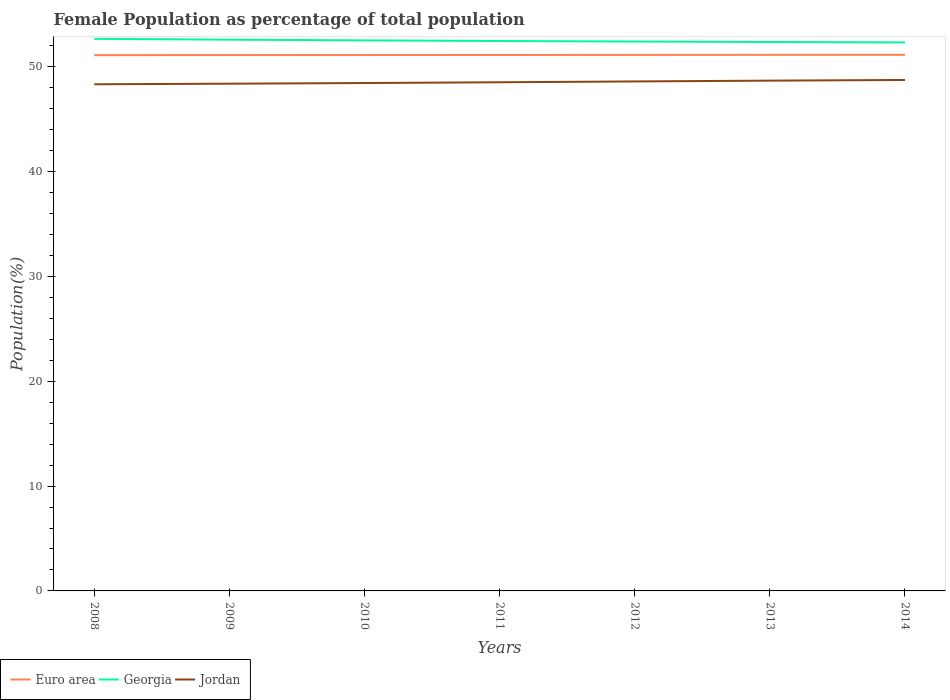How many different coloured lines are there?
Your answer should be very brief. 3. Is the number of lines equal to the number of legend labels?
Provide a succinct answer. Yes. Across all years, what is the maximum female population in in Georgia?
Provide a succinct answer. 52.33. What is the total female population in in Jordan in the graph?
Ensure brevity in your answer.  -0.06. What is the difference between the highest and the second highest female population in in Euro area?
Your response must be concise. 0.03. What is the difference between two consecutive major ticks on the Y-axis?
Your response must be concise. 10. How are the legend labels stacked?
Ensure brevity in your answer.  Horizontal. What is the title of the graph?
Keep it short and to the point. Female Population as percentage of total population. Does "Dominica" appear as one of the legend labels in the graph?
Your response must be concise. No. What is the label or title of the Y-axis?
Ensure brevity in your answer.  Population(%). What is the Population(%) of Euro area in 2008?
Your response must be concise. 51.12. What is the Population(%) in Georgia in 2008?
Offer a terse response. 52.67. What is the Population(%) in Jordan in 2008?
Your response must be concise. 48.34. What is the Population(%) of Euro area in 2009?
Give a very brief answer. 51.12. What is the Population(%) in Georgia in 2009?
Provide a short and direct response. 52.59. What is the Population(%) of Jordan in 2009?
Provide a short and direct response. 48.39. What is the Population(%) of Euro area in 2010?
Offer a terse response. 51.13. What is the Population(%) of Georgia in 2010?
Offer a terse response. 52.52. What is the Population(%) in Jordan in 2010?
Ensure brevity in your answer.  48.45. What is the Population(%) of Euro area in 2011?
Keep it short and to the point. 51.13. What is the Population(%) in Georgia in 2011?
Provide a succinct answer. 52.46. What is the Population(%) of Jordan in 2011?
Offer a terse response. 48.53. What is the Population(%) in Euro area in 2012?
Offer a terse response. 51.14. What is the Population(%) of Georgia in 2012?
Your response must be concise. 52.41. What is the Population(%) of Jordan in 2012?
Your answer should be compact. 48.61. What is the Population(%) in Euro area in 2013?
Offer a very short reply. 51.14. What is the Population(%) of Georgia in 2013?
Make the answer very short. 52.37. What is the Population(%) in Jordan in 2013?
Provide a short and direct response. 48.68. What is the Population(%) in Euro area in 2014?
Your answer should be very brief. 51.14. What is the Population(%) in Georgia in 2014?
Provide a succinct answer. 52.33. What is the Population(%) in Jordan in 2014?
Ensure brevity in your answer.  48.75. Across all years, what is the maximum Population(%) of Euro area?
Give a very brief answer. 51.14. Across all years, what is the maximum Population(%) of Georgia?
Make the answer very short. 52.67. Across all years, what is the maximum Population(%) in Jordan?
Provide a short and direct response. 48.75. Across all years, what is the minimum Population(%) of Euro area?
Your answer should be very brief. 51.12. Across all years, what is the minimum Population(%) in Georgia?
Provide a succinct answer. 52.33. Across all years, what is the minimum Population(%) of Jordan?
Ensure brevity in your answer.  48.34. What is the total Population(%) in Euro area in the graph?
Offer a very short reply. 357.92. What is the total Population(%) of Georgia in the graph?
Your answer should be very brief. 367.37. What is the total Population(%) of Jordan in the graph?
Give a very brief answer. 339.75. What is the difference between the Population(%) in Euro area in 2008 and that in 2009?
Your answer should be very brief. -0. What is the difference between the Population(%) of Georgia in 2008 and that in 2009?
Ensure brevity in your answer.  0.08. What is the difference between the Population(%) in Jordan in 2008 and that in 2009?
Provide a short and direct response. -0.05. What is the difference between the Population(%) of Euro area in 2008 and that in 2010?
Provide a succinct answer. -0.01. What is the difference between the Population(%) of Georgia in 2008 and that in 2010?
Your answer should be very brief. 0.15. What is the difference between the Population(%) of Jordan in 2008 and that in 2010?
Give a very brief answer. -0.12. What is the difference between the Population(%) of Euro area in 2008 and that in 2011?
Ensure brevity in your answer.  -0.01. What is the difference between the Population(%) in Georgia in 2008 and that in 2011?
Provide a short and direct response. 0.21. What is the difference between the Population(%) in Jordan in 2008 and that in 2011?
Offer a terse response. -0.19. What is the difference between the Population(%) of Euro area in 2008 and that in 2012?
Offer a terse response. -0.02. What is the difference between the Population(%) of Georgia in 2008 and that in 2012?
Your answer should be compact. 0.26. What is the difference between the Population(%) of Jordan in 2008 and that in 2012?
Offer a terse response. -0.27. What is the difference between the Population(%) of Euro area in 2008 and that in 2013?
Ensure brevity in your answer.  -0.03. What is the difference between the Population(%) of Georgia in 2008 and that in 2013?
Provide a short and direct response. 0.3. What is the difference between the Population(%) in Jordan in 2008 and that in 2013?
Your answer should be compact. -0.35. What is the difference between the Population(%) of Euro area in 2008 and that in 2014?
Provide a short and direct response. -0.03. What is the difference between the Population(%) in Georgia in 2008 and that in 2014?
Keep it short and to the point. 0.34. What is the difference between the Population(%) of Jordan in 2008 and that in 2014?
Your response must be concise. -0.41. What is the difference between the Population(%) of Euro area in 2009 and that in 2010?
Your answer should be compact. -0. What is the difference between the Population(%) of Georgia in 2009 and that in 2010?
Provide a succinct answer. 0.07. What is the difference between the Population(%) of Jordan in 2009 and that in 2010?
Offer a very short reply. -0.06. What is the difference between the Population(%) in Euro area in 2009 and that in 2011?
Give a very brief answer. -0.01. What is the difference between the Population(%) of Georgia in 2009 and that in 2011?
Offer a terse response. 0.13. What is the difference between the Population(%) in Jordan in 2009 and that in 2011?
Give a very brief answer. -0.14. What is the difference between the Population(%) of Euro area in 2009 and that in 2012?
Give a very brief answer. -0.02. What is the difference between the Population(%) in Georgia in 2009 and that in 2012?
Make the answer very short. 0.18. What is the difference between the Population(%) in Jordan in 2009 and that in 2012?
Keep it short and to the point. -0.21. What is the difference between the Population(%) of Euro area in 2009 and that in 2013?
Provide a short and direct response. -0.02. What is the difference between the Population(%) in Georgia in 2009 and that in 2013?
Offer a terse response. 0.22. What is the difference between the Population(%) of Jordan in 2009 and that in 2013?
Your answer should be very brief. -0.29. What is the difference between the Population(%) in Euro area in 2009 and that in 2014?
Keep it short and to the point. -0.02. What is the difference between the Population(%) in Georgia in 2009 and that in 2014?
Provide a succinct answer. 0.26. What is the difference between the Population(%) of Jordan in 2009 and that in 2014?
Provide a short and direct response. -0.36. What is the difference between the Population(%) of Euro area in 2010 and that in 2011?
Offer a very short reply. -0.01. What is the difference between the Population(%) of Georgia in 2010 and that in 2011?
Offer a very short reply. 0.06. What is the difference between the Population(%) of Jordan in 2010 and that in 2011?
Provide a succinct answer. -0.07. What is the difference between the Population(%) in Euro area in 2010 and that in 2012?
Ensure brevity in your answer.  -0.01. What is the difference between the Population(%) in Georgia in 2010 and that in 2012?
Your answer should be very brief. 0.11. What is the difference between the Population(%) in Jordan in 2010 and that in 2012?
Give a very brief answer. -0.15. What is the difference between the Population(%) of Euro area in 2010 and that in 2013?
Ensure brevity in your answer.  -0.02. What is the difference between the Population(%) of Georgia in 2010 and that in 2013?
Make the answer very short. 0.15. What is the difference between the Population(%) in Jordan in 2010 and that in 2013?
Offer a terse response. -0.23. What is the difference between the Population(%) of Euro area in 2010 and that in 2014?
Ensure brevity in your answer.  -0.02. What is the difference between the Population(%) in Georgia in 2010 and that in 2014?
Your answer should be very brief. 0.19. What is the difference between the Population(%) of Jordan in 2010 and that in 2014?
Offer a very short reply. -0.29. What is the difference between the Population(%) of Euro area in 2011 and that in 2012?
Provide a succinct answer. -0.01. What is the difference between the Population(%) of Georgia in 2011 and that in 2012?
Offer a terse response. 0.05. What is the difference between the Population(%) in Jordan in 2011 and that in 2012?
Provide a succinct answer. -0.08. What is the difference between the Population(%) of Euro area in 2011 and that in 2013?
Provide a succinct answer. -0.01. What is the difference between the Population(%) in Georgia in 2011 and that in 2013?
Ensure brevity in your answer.  0.09. What is the difference between the Population(%) in Jordan in 2011 and that in 2013?
Give a very brief answer. -0.16. What is the difference between the Population(%) in Euro area in 2011 and that in 2014?
Offer a terse response. -0.01. What is the difference between the Population(%) of Georgia in 2011 and that in 2014?
Offer a very short reply. 0.13. What is the difference between the Population(%) of Jordan in 2011 and that in 2014?
Keep it short and to the point. -0.22. What is the difference between the Population(%) in Euro area in 2012 and that in 2013?
Provide a short and direct response. -0.01. What is the difference between the Population(%) of Georgia in 2012 and that in 2013?
Offer a very short reply. 0.04. What is the difference between the Population(%) of Jordan in 2012 and that in 2013?
Your answer should be compact. -0.08. What is the difference between the Population(%) of Euro area in 2012 and that in 2014?
Give a very brief answer. -0.01. What is the difference between the Population(%) of Georgia in 2012 and that in 2014?
Your answer should be very brief. 0.08. What is the difference between the Population(%) in Jordan in 2012 and that in 2014?
Keep it short and to the point. -0.14. What is the difference between the Population(%) in Euro area in 2013 and that in 2014?
Provide a succinct answer. -0. What is the difference between the Population(%) of Georgia in 2013 and that in 2014?
Offer a very short reply. 0.04. What is the difference between the Population(%) in Jordan in 2013 and that in 2014?
Make the answer very short. -0.06. What is the difference between the Population(%) of Euro area in 2008 and the Population(%) of Georgia in 2009?
Make the answer very short. -1.48. What is the difference between the Population(%) in Euro area in 2008 and the Population(%) in Jordan in 2009?
Make the answer very short. 2.72. What is the difference between the Population(%) in Georgia in 2008 and the Population(%) in Jordan in 2009?
Your answer should be compact. 4.28. What is the difference between the Population(%) of Euro area in 2008 and the Population(%) of Georgia in 2010?
Your response must be concise. -1.41. What is the difference between the Population(%) of Euro area in 2008 and the Population(%) of Jordan in 2010?
Offer a very short reply. 2.66. What is the difference between the Population(%) in Georgia in 2008 and the Population(%) in Jordan in 2010?
Provide a short and direct response. 4.22. What is the difference between the Population(%) in Euro area in 2008 and the Population(%) in Georgia in 2011?
Your answer should be very brief. -1.35. What is the difference between the Population(%) of Euro area in 2008 and the Population(%) of Jordan in 2011?
Offer a very short reply. 2.59. What is the difference between the Population(%) of Georgia in 2008 and the Population(%) of Jordan in 2011?
Provide a succinct answer. 4.14. What is the difference between the Population(%) in Euro area in 2008 and the Population(%) in Georgia in 2012?
Your answer should be very brief. -1.3. What is the difference between the Population(%) of Euro area in 2008 and the Population(%) of Jordan in 2012?
Your answer should be very brief. 2.51. What is the difference between the Population(%) in Georgia in 2008 and the Population(%) in Jordan in 2012?
Provide a short and direct response. 4.06. What is the difference between the Population(%) in Euro area in 2008 and the Population(%) in Georgia in 2013?
Provide a succinct answer. -1.25. What is the difference between the Population(%) of Euro area in 2008 and the Population(%) of Jordan in 2013?
Your response must be concise. 2.43. What is the difference between the Population(%) in Georgia in 2008 and the Population(%) in Jordan in 2013?
Give a very brief answer. 3.99. What is the difference between the Population(%) in Euro area in 2008 and the Population(%) in Georgia in 2014?
Your answer should be compact. -1.22. What is the difference between the Population(%) in Euro area in 2008 and the Population(%) in Jordan in 2014?
Offer a very short reply. 2.37. What is the difference between the Population(%) in Georgia in 2008 and the Population(%) in Jordan in 2014?
Make the answer very short. 3.92. What is the difference between the Population(%) of Euro area in 2009 and the Population(%) of Georgia in 2010?
Your response must be concise. -1.4. What is the difference between the Population(%) in Euro area in 2009 and the Population(%) in Jordan in 2010?
Give a very brief answer. 2.67. What is the difference between the Population(%) in Georgia in 2009 and the Population(%) in Jordan in 2010?
Your answer should be compact. 4.14. What is the difference between the Population(%) of Euro area in 2009 and the Population(%) of Georgia in 2011?
Your response must be concise. -1.34. What is the difference between the Population(%) in Euro area in 2009 and the Population(%) in Jordan in 2011?
Make the answer very short. 2.59. What is the difference between the Population(%) of Georgia in 2009 and the Population(%) of Jordan in 2011?
Provide a short and direct response. 4.07. What is the difference between the Population(%) in Euro area in 2009 and the Population(%) in Georgia in 2012?
Your answer should be very brief. -1.29. What is the difference between the Population(%) of Euro area in 2009 and the Population(%) of Jordan in 2012?
Keep it short and to the point. 2.51. What is the difference between the Population(%) in Georgia in 2009 and the Population(%) in Jordan in 2012?
Offer a terse response. 3.99. What is the difference between the Population(%) in Euro area in 2009 and the Population(%) in Georgia in 2013?
Provide a short and direct response. -1.25. What is the difference between the Population(%) in Euro area in 2009 and the Population(%) in Jordan in 2013?
Provide a succinct answer. 2.44. What is the difference between the Population(%) in Georgia in 2009 and the Population(%) in Jordan in 2013?
Offer a terse response. 3.91. What is the difference between the Population(%) in Euro area in 2009 and the Population(%) in Georgia in 2014?
Keep it short and to the point. -1.21. What is the difference between the Population(%) of Euro area in 2009 and the Population(%) of Jordan in 2014?
Make the answer very short. 2.37. What is the difference between the Population(%) of Georgia in 2009 and the Population(%) of Jordan in 2014?
Your answer should be very brief. 3.85. What is the difference between the Population(%) of Euro area in 2010 and the Population(%) of Georgia in 2011?
Your answer should be very brief. -1.34. What is the difference between the Population(%) of Euro area in 2010 and the Population(%) of Jordan in 2011?
Give a very brief answer. 2.6. What is the difference between the Population(%) in Georgia in 2010 and the Population(%) in Jordan in 2011?
Keep it short and to the point. 4. What is the difference between the Population(%) in Euro area in 2010 and the Population(%) in Georgia in 2012?
Your answer should be very brief. -1.29. What is the difference between the Population(%) of Euro area in 2010 and the Population(%) of Jordan in 2012?
Your answer should be compact. 2.52. What is the difference between the Population(%) of Georgia in 2010 and the Population(%) of Jordan in 2012?
Your response must be concise. 3.92. What is the difference between the Population(%) of Euro area in 2010 and the Population(%) of Georgia in 2013?
Your answer should be compact. -1.24. What is the difference between the Population(%) of Euro area in 2010 and the Population(%) of Jordan in 2013?
Offer a very short reply. 2.44. What is the difference between the Population(%) in Georgia in 2010 and the Population(%) in Jordan in 2013?
Your answer should be very brief. 3.84. What is the difference between the Population(%) of Euro area in 2010 and the Population(%) of Georgia in 2014?
Ensure brevity in your answer.  -1.21. What is the difference between the Population(%) in Euro area in 2010 and the Population(%) in Jordan in 2014?
Offer a very short reply. 2.38. What is the difference between the Population(%) of Georgia in 2010 and the Population(%) of Jordan in 2014?
Your answer should be very brief. 3.78. What is the difference between the Population(%) in Euro area in 2011 and the Population(%) in Georgia in 2012?
Provide a short and direct response. -1.28. What is the difference between the Population(%) in Euro area in 2011 and the Population(%) in Jordan in 2012?
Provide a short and direct response. 2.52. What is the difference between the Population(%) of Georgia in 2011 and the Population(%) of Jordan in 2012?
Provide a succinct answer. 3.86. What is the difference between the Population(%) in Euro area in 2011 and the Population(%) in Georgia in 2013?
Provide a succinct answer. -1.24. What is the difference between the Population(%) in Euro area in 2011 and the Population(%) in Jordan in 2013?
Keep it short and to the point. 2.45. What is the difference between the Population(%) of Georgia in 2011 and the Population(%) of Jordan in 2013?
Offer a very short reply. 3.78. What is the difference between the Population(%) of Euro area in 2011 and the Population(%) of Georgia in 2014?
Offer a terse response. -1.2. What is the difference between the Population(%) of Euro area in 2011 and the Population(%) of Jordan in 2014?
Provide a short and direct response. 2.38. What is the difference between the Population(%) in Georgia in 2011 and the Population(%) in Jordan in 2014?
Give a very brief answer. 3.72. What is the difference between the Population(%) in Euro area in 2012 and the Population(%) in Georgia in 2013?
Offer a terse response. -1.23. What is the difference between the Population(%) of Euro area in 2012 and the Population(%) of Jordan in 2013?
Your answer should be very brief. 2.45. What is the difference between the Population(%) of Georgia in 2012 and the Population(%) of Jordan in 2013?
Make the answer very short. 3.73. What is the difference between the Population(%) in Euro area in 2012 and the Population(%) in Georgia in 2014?
Provide a short and direct response. -1.19. What is the difference between the Population(%) in Euro area in 2012 and the Population(%) in Jordan in 2014?
Your response must be concise. 2.39. What is the difference between the Population(%) in Georgia in 2012 and the Population(%) in Jordan in 2014?
Provide a short and direct response. 3.67. What is the difference between the Population(%) in Euro area in 2013 and the Population(%) in Georgia in 2014?
Ensure brevity in your answer.  -1.19. What is the difference between the Population(%) of Euro area in 2013 and the Population(%) of Jordan in 2014?
Make the answer very short. 2.4. What is the difference between the Population(%) in Georgia in 2013 and the Population(%) in Jordan in 2014?
Offer a terse response. 3.62. What is the average Population(%) of Euro area per year?
Your answer should be very brief. 51.13. What is the average Population(%) in Georgia per year?
Make the answer very short. 52.48. What is the average Population(%) in Jordan per year?
Give a very brief answer. 48.54. In the year 2008, what is the difference between the Population(%) in Euro area and Population(%) in Georgia?
Offer a terse response. -1.55. In the year 2008, what is the difference between the Population(%) of Euro area and Population(%) of Jordan?
Ensure brevity in your answer.  2.78. In the year 2008, what is the difference between the Population(%) of Georgia and Population(%) of Jordan?
Provide a short and direct response. 4.33. In the year 2009, what is the difference between the Population(%) in Euro area and Population(%) in Georgia?
Offer a very short reply. -1.47. In the year 2009, what is the difference between the Population(%) of Euro area and Population(%) of Jordan?
Your answer should be very brief. 2.73. In the year 2009, what is the difference between the Population(%) of Georgia and Population(%) of Jordan?
Your answer should be very brief. 4.2. In the year 2010, what is the difference between the Population(%) in Euro area and Population(%) in Georgia?
Give a very brief answer. -1.4. In the year 2010, what is the difference between the Population(%) of Euro area and Population(%) of Jordan?
Your answer should be very brief. 2.67. In the year 2010, what is the difference between the Population(%) of Georgia and Population(%) of Jordan?
Ensure brevity in your answer.  4.07. In the year 2011, what is the difference between the Population(%) of Euro area and Population(%) of Georgia?
Offer a very short reply. -1.33. In the year 2011, what is the difference between the Population(%) in Euro area and Population(%) in Jordan?
Your answer should be very brief. 2.6. In the year 2011, what is the difference between the Population(%) in Georgia and Population(%) in Jordan?
Your answer should be very brief. 3.94. In the year 2012, what is the difference between the Population(%) in Euro area and Population(%) in Georgia?
Ensure brevity in your answer.  -1.28. In the year 2012, what is the difference between the Population(%) in Euro area and Population(%) in Jordan?
Keep it short and to the point. 2.53. In the year 2012, what is the difference between the Population(%) of Georgia and Population(%) of Jordan?
Make the answer very short. 3.81. In the year 2013, what is the difference between the Population(%) of Euro area and Population(%) of Georgia?
Give a very brief answer. -1.23. In the year 2013, what is the difference between the Population(%) in Euro area and Population(%) in Jordan?
Ensure brevity in your answer.  2.46. In the year 2013, what is the difference between the Population(%) in Georgia and Population(%) in Jordan?
Offer a terse response. 3.69. In the year 2014, what is the difference between the Population(%) in Euro area and Population(%) in Georgia?
Your answer should be very brief. -1.19. In the year 2014, what is the difference between the Population(%) in Euro area and Population(%) in Jordan?
Offer a very short reply. 2.4. In the year 2014, what is the difference between the Population(%) in Georgia and Population(%) in Jordan?
Provide a succinct answer. 3.58. What is the ratio of the Population(%) in Euro area in 2008 to that in 2009?
Keep it short and to the point. 1. What is the ratio of the Population(%) of Georgia in 2008 to that in 2009?
Ensure brevity in your answer.  1. What is the ratio of the Population(%) of Euro area in 2008 to that in 2010?
Make the answer very short. 1. What is the ratio of the Population(%) in Georgia in 2008 to that in 2010?
Ensure brevity in your answer.  1. What is the ratio of the Population(%) of Jordan in 2008 to that in 2010?
Offer a terse response. 1. What is the ratio of the Population(%) in Jordan in 2008 to that in 2011?
Your answer should be compact. 1. What is the ratio of the Population(%) of Euro area in 2008 to that in 2013?
Keep it short and to the point. 1. What is the ratio of the Population(%) of Jordan in 2008 to that in 2013?
Give a very brief answer. 0.99. What is the ratio of the Population(%) of Jordan in 2008 to that in 2014?
Provide a short and direct response. 0.99. What is the ratio of the Population(%) of Euro area in 2009 to that in 2010?
Your answer should be compact. 1. What is the ratio of the Population(%) in Jordan in 2009 to that in 2010?
Offer a terse response. 1. What is the ratio of the Population(%) in Georgia in 2009 to that in 2012?
Offer a terse response. 1. What is the ratio of the Population(%) of Jordan in 2009 to that in 2013?
Your answer should be compact. 0.99. What is the ratio of the Population(%) in Georgia in 2009 to that in 2014?
Provide a succinct answer. 1. What is the ratio of the Population(%) of Jordan in 2009 to that in 2014?
Offer a very short reply. 0.99. What is the ratio of the Population(%) of Georgia in 2010 to that in 2011?
Offer a very short reply. 1. What is the ratio of the Population(%) in Jordan in 2010 to that in 2011?
Your response must be concise. 1. What is the ratio of the Population(%) of Euro area in 2010 to that in 2012?
Make the answer very short. 1. What is the ratio of the Population(%) of Georgia in 2010 to that in 2012?
Offer a terse response. 1. What is the ratio of the Population(%) in Euro area in 2010 to that in 2013?
Your answer should be compact. 1. What is the ratio of the Population(%) in Georgia in 2010 to that in 2013?
Give a very brief answer. 1. What is the ratio of the Population(%) of Jordan in 2010 to that in 2013?
Your answer should be very brief. 1. What is the ratio of the Population(%) of Euro area in 2010 to that in 2014?
Give a very brief answer. 1. What is the ratio of the Population(%) of Euro area in 2011 to that in 2013?
Ensure brevity in your answer.  1. What is the ratio of the Population(%) in Euro area in 2012 to that in 2013?
Your answer should be compact. 1. What is the ratio of the Population(%) in Georgia in 2012 to that in 2013?
Your answer should be compact. 1. What is the ratio of the Population(%) of Georgia in 2012 to that in 2014?
Give a very brief answer. 1. What is the ratio of the Population(%) in Georgia in 2013 to that in 2014?
Provide a short and direct response. 1. What is the ratio of the Population(%) in Jordan in 2013 to that in 2014?
Give a very brief answer. 1. What is the difference between the highest and the second highest Population(%) of Euro area?
Offer a very short reply. 0. What is the difference between the highest and the second highest Population(%) of Georgia?
Offer a very short reply. 0.08. What is the difference between the highest and the second highest Population(%) in Jordan?
Your answer should be compact. 0.06. What is the difference between the highest and the lowest Population(%) of Euro area?
Your answer should be very brief. 0.03. What is the difference between the highest and the lowest Population(%) of Georgia?
Your answer should be very brief. 0.34. What is the difference between the highest and the lowest Population(%) of Jordan?
Provide a short and direct response. 0.41. 